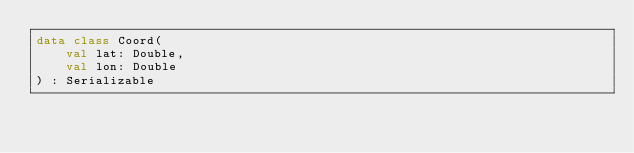Convert code to text. <code><loc_0><loc_0><loc_500><loc_500><_Kotlin_>data class Coord(
    val lat: Double,
    val lon: Double
) : Serializable</code> 